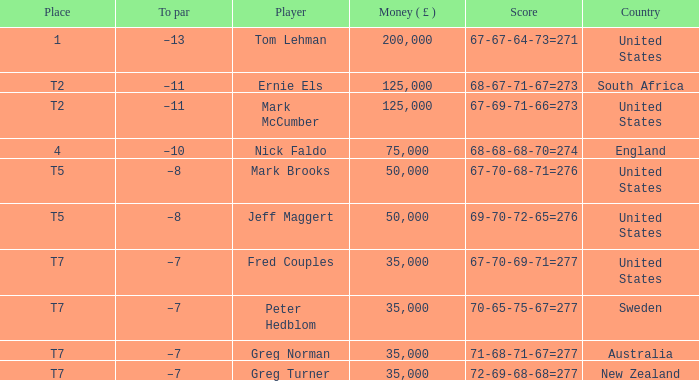What is the highest Money ( £ ), when Player is "Peter Hedblom"? 35000.0. 